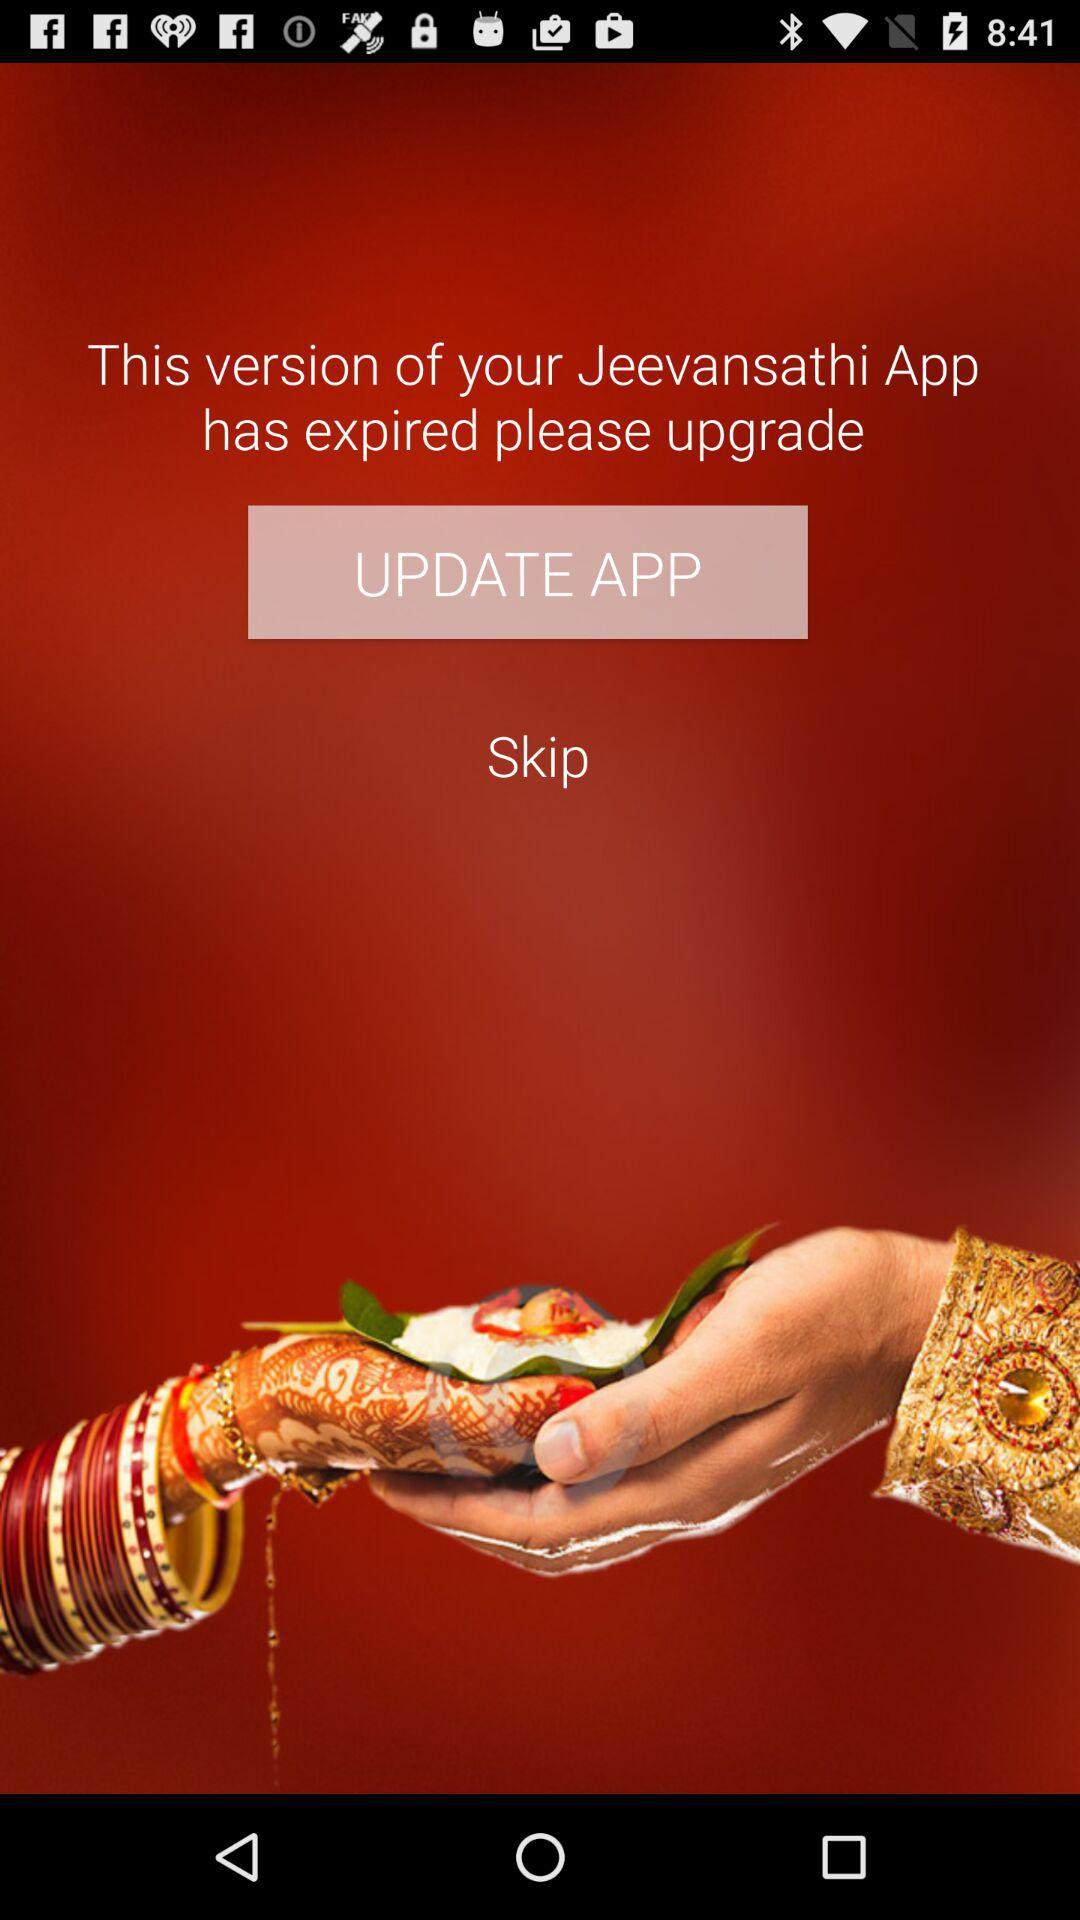What's the application name? The application name is "Jeevansathi". 